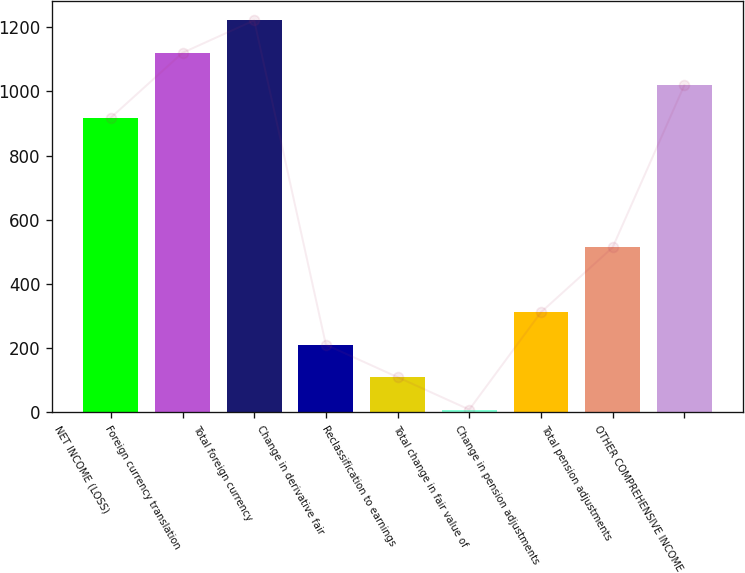<chart> <loc_0><loc_0><loc_500><loc_500><bar_chart><fcel>NET INCOME (LOSS)<fcel>Foreign currency translation<fcel>Total foreign currency<fcel>Change in derivative fair<fcel>Reclassification to earnings<fcel>Total change in fair value of<fcel>Change in pension adjustments<fcel>Total pension adjustments<fcel>OTHER COMPREHENSIVE INCOME<nl><fcel>918<fcel>1120<fcel>1221<fcel>211<fcel>110<fcel>9<fcel>312<fcel>514<fcel>1019<nl></chart> 